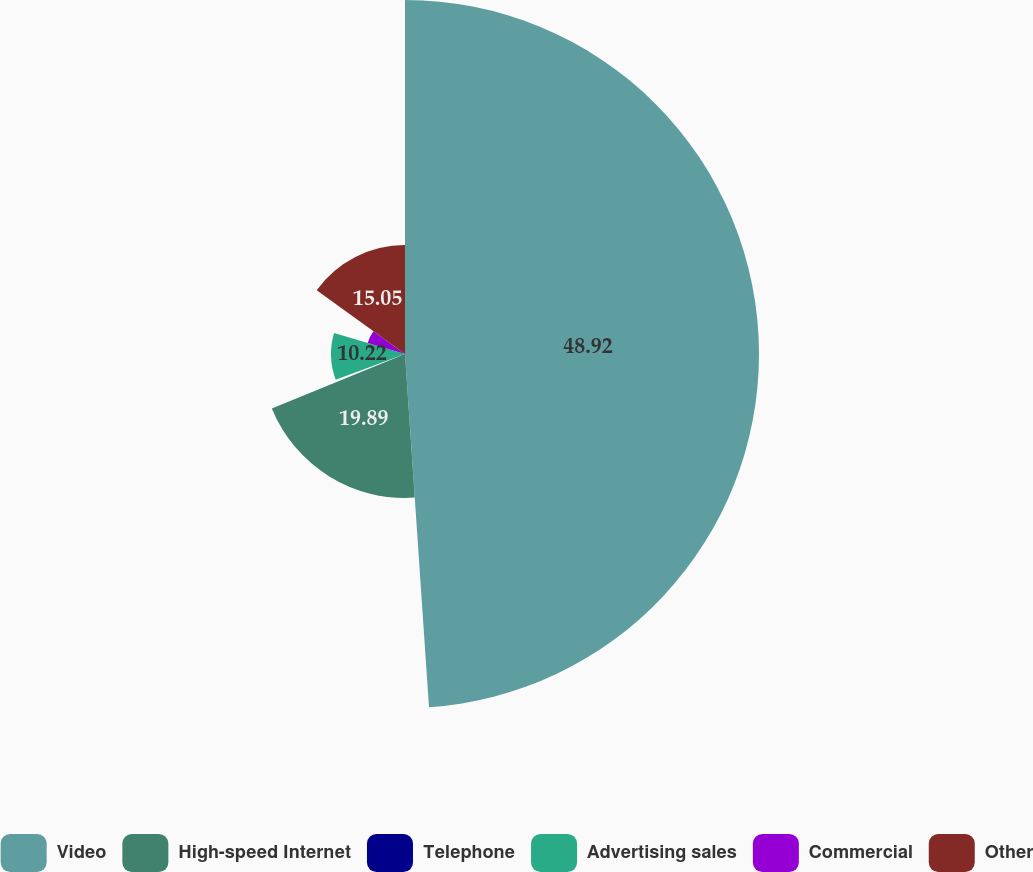Convert chart to OTSL. <chart><loc_0><loc_0><loc_500><loc_500><pie_chart><fcel>Video<fcel>High-speed Internet<fcel>Telephone<fcel>Advertising sales<fcel>Commercial<fcel>Other<nl><fcel>48.92%<fcel>19.89%<fcel>0.54%<fcel>10.22%<fcel>5.38%<fcel>15.05%<nl></chart> 